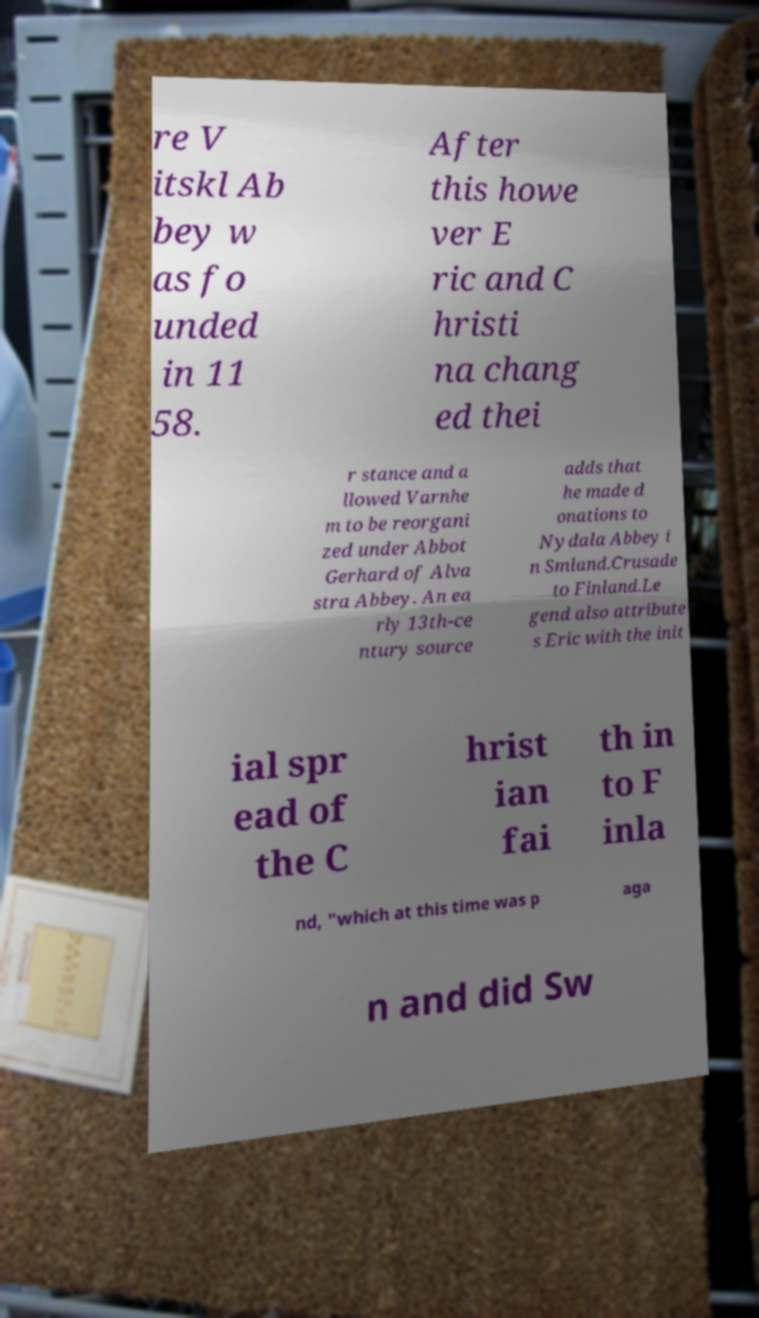Can you accurately transcribe the text from the provided image for me? re V itskl Ab bey w as fo unded in 11 58. After this howe ver E ric and C hristi na chang ed thei r stance and a llowed Varnhe m to be reorgani zed under Abbot Gerhard of Alva stra Abbey. An ea rly 13th-ce ntury source adds that he made d onations to Nydala Abbey i n Smland.Crusade to Finland.Le gend also attribute s Eric with the init ial spr ead of the C hrist ian fai th in to F inla nd, "which at this time was p aga n and did Sw 